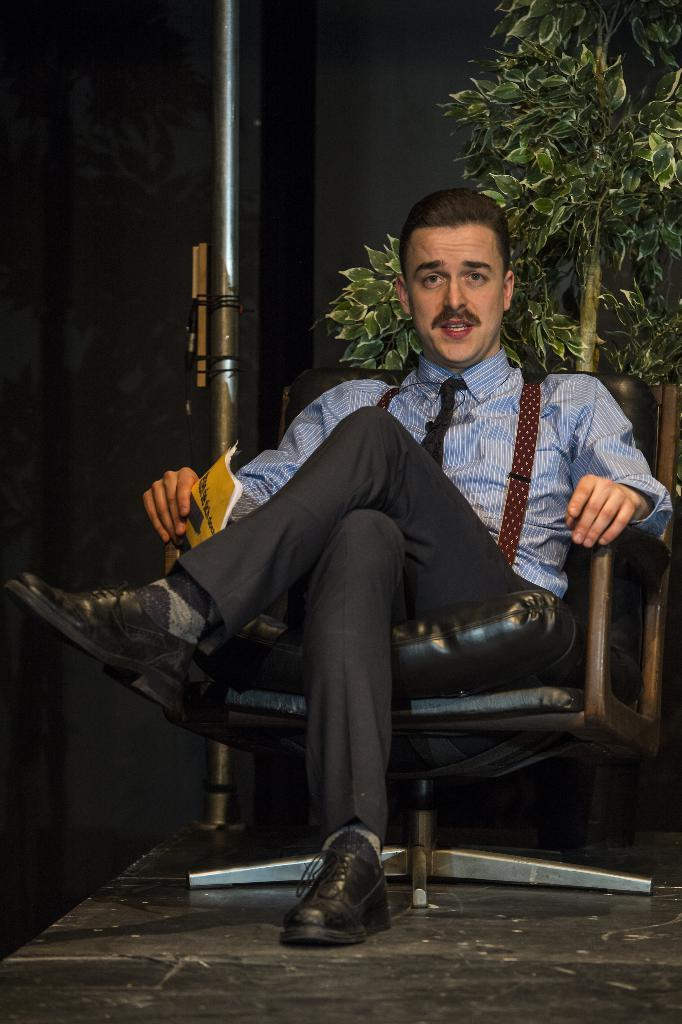What is the person in the image doing? The person is sitting on a chair in the image. What is the person holding in the image? The person is holding a book. What can be seen in the image besides the person and the book? There is a plant visible in the image. What is the color of the wall on the right side of the image? The wall on the right side of the image is black. What subject is the person teaching in the image? There is no indication in the image that the person is teaching, nor is there any information about the subject being taught. 